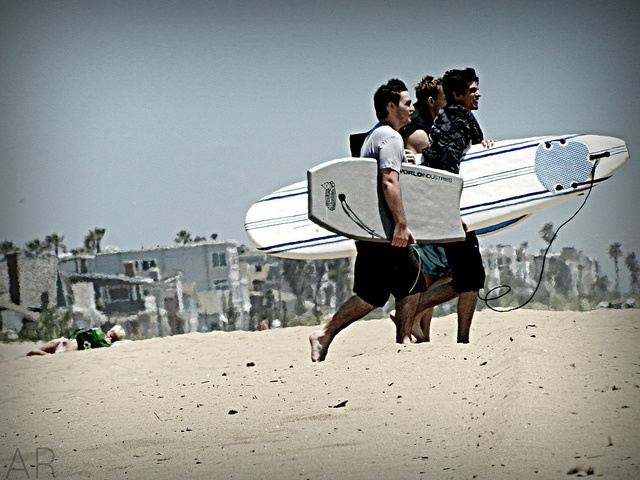Describe the objects in this image and their specific colors. I can see surfboard in purple, white, darkgray, and lightblue tones, people in purple, black, lightgray, maroon, and darkgray tones, surfboard in purple, darkgray, black, lightgray, and gray tones, people in purple, black, maroon, gray, and lightgray tones, and people in purple, black, maroon, gray, and teal tones in this image. 